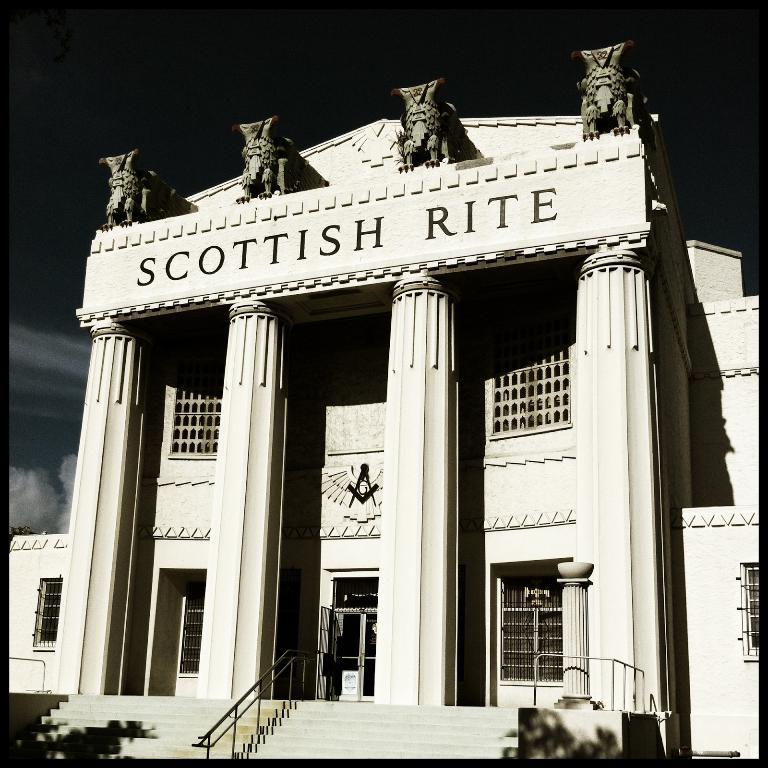What is the main structure in the image? There is a building in the image. What decorative elements are present on the building? The building has four statues on it. What can be seen in the foreground of the image? There is iron railing in the foreground of the image. What is visible in the background of the image? The sky is visible in the background of the image. What type of acoustics can be heard from the ants in the image? There are no ants present in the image, and therefore no acoustics can be heard from them. 